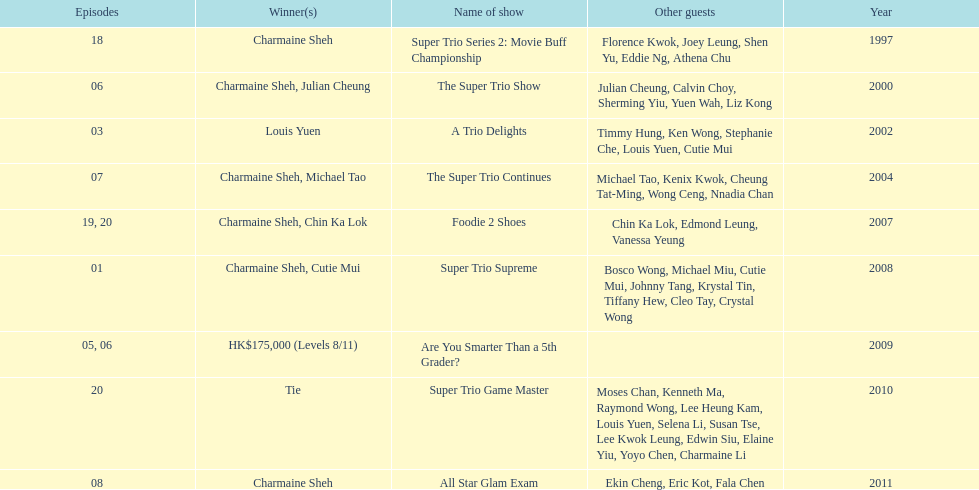What is the number of other guests in the 2002 show "a trio delights"? 5. 